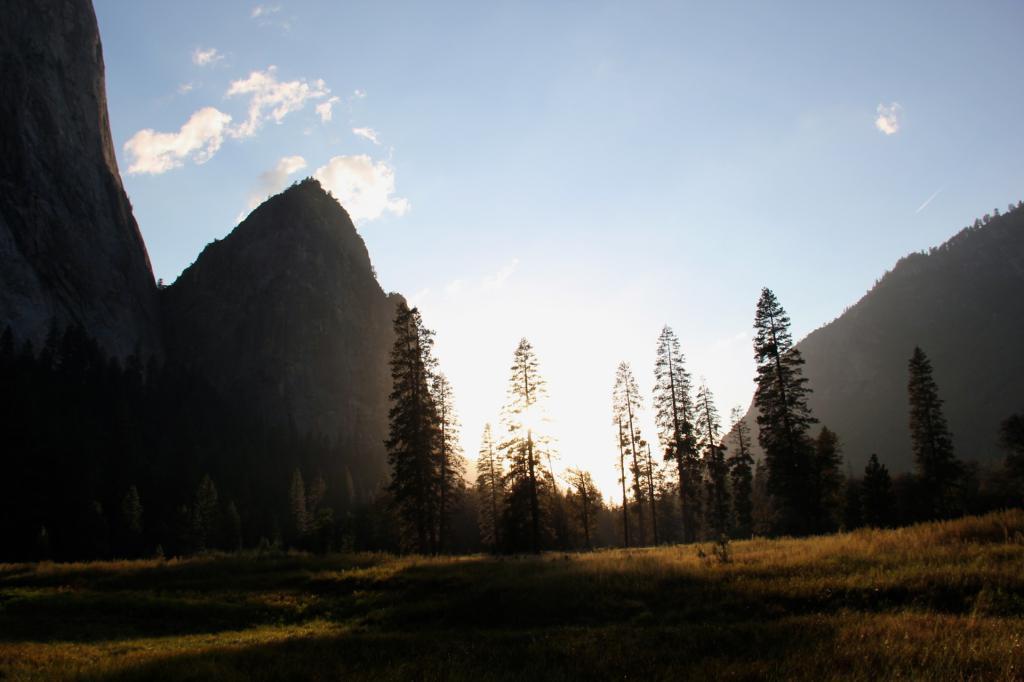In one or two sentences, can you explain what this image depicts? In this image we can see trees, plants, grass, hills, sky and clouds. 